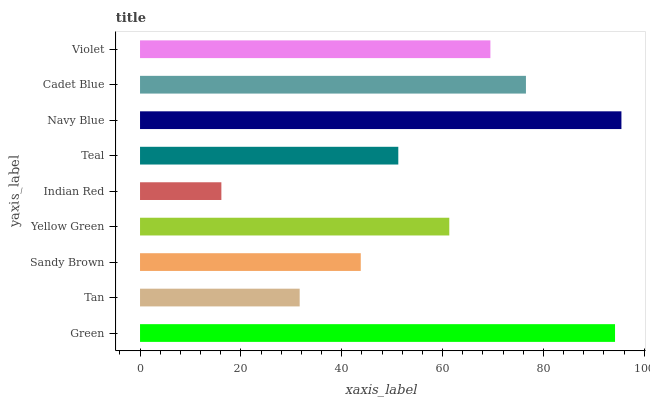Is Indian Red the minimum?
Answer yes or no. Yes. Is Navy Blue the maximum?
Answer yes or no. Yes. Is Tan the minimum?
Answer yes or no. No. Is Tan the maximum?
Answer yes or no. No. Is Green greater than Tan?
Answer yes or no. Yes. Is Tan less than Green?
Answer yes or no. Yes. Is Tan greater than Green?
Answer yes or no. No. Is Green less than Tan?
Answer yes or no. No. Is Yellow Green the high median?
Answer yes or no. Yes. Is Yellow Green the low median?
Answer yes or no. Yes. Is Teal the high median?
Answer yes or no. No. Is Violet the low median?
Answer yes or no. No. 